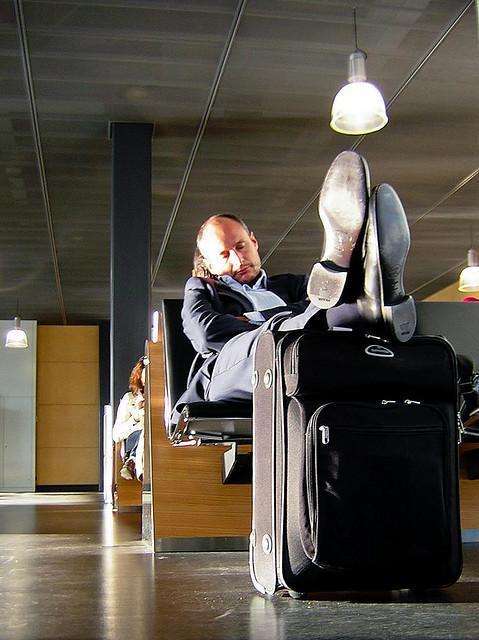How many people are in the picture?
Give a very brief answer. 2. How many birds are standing in the pizza box?
Give a very brief answer. 0. 